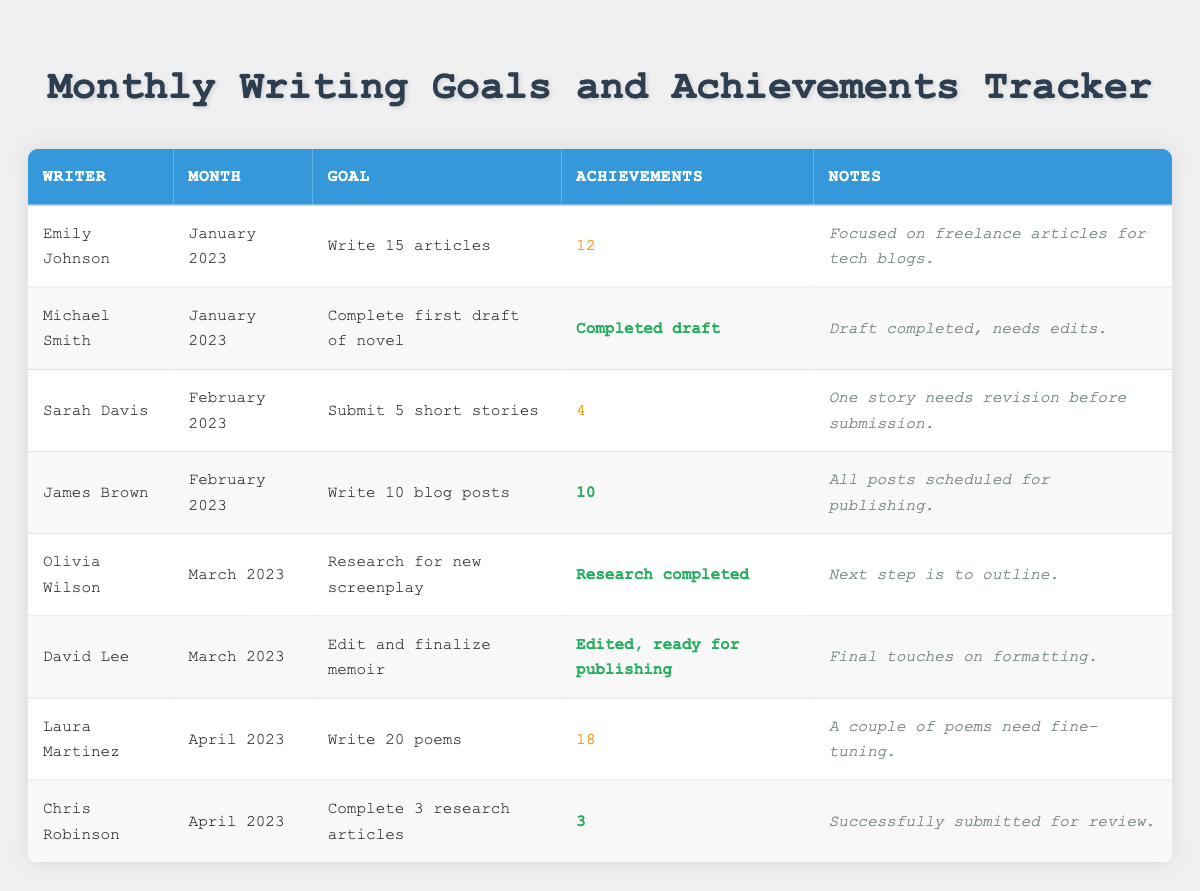What writing goal did Emily Johnson have for January 2023? The table indicates that Emily Johnson's goal for January 2023 was to "Write 15 articles." This can be directly found in the "Goal" column corresponding to her name.
Answer: Write 15 articles How many articles did Emily Johnson achieve in January 2023? In the "Achievements" column for Emily Johnson, the table states that she achieved "12." This indicates the number of articles she completed against her goal.
Answer: 12 Which writer submitted fewer short stories than their goal in February 2023? Looking at the "Achievements" for Sarah Davis, who had a goal to "Submit 5 short stories," we see she achieved 4. Since she didn't meet her goal, she is the one who submitted fewer stories than her goal in that month.
Answer: Sarah Davis What is the total number of poems written by Laura Martinez in April 2023 compared to her goal? The table shows Laura Martinez's goal was to "Write 20 poems," and she achieved "18." To determine how many fewer she wrote than her goal, we subtract 18 from 20, resulting in 2 poems less.
Answer: 2 Did Chris Robinson meet his writing goal in April 2023? Chris Robinson had a goal to "Complete 3 research articles," and the table states he achieved "3." Since he completed all articles he set out to write, he did meet his goal.
Answer: Yes Which month had a writer who completed a draft of their novel? The table identifies Michael Smith, who completed a draft of his novel in January 2023. This is evident in the "Achievements" column under his entry.
Answer: January 2023 Which writer had a goal involving research, and what was the outcome? Olivia Wilson's goal was to "Research for new screenplay," and the table indicates her achievement was "Research completed." This shows she successfully reached her research goal.
Answer: Olivia Wilson; Research completed What is the difference between the total articles achieved by James Brown and Emily Johnson in January 2023? James Brown achieved 10 blog posts while Emily Johnson achieved 12 articles. The difference can be calculated by subtracting James's achievement from Emily's: 12 - 10 = 2. Therefore, Emily achieved 2 more articles than James.
Answer: 2 